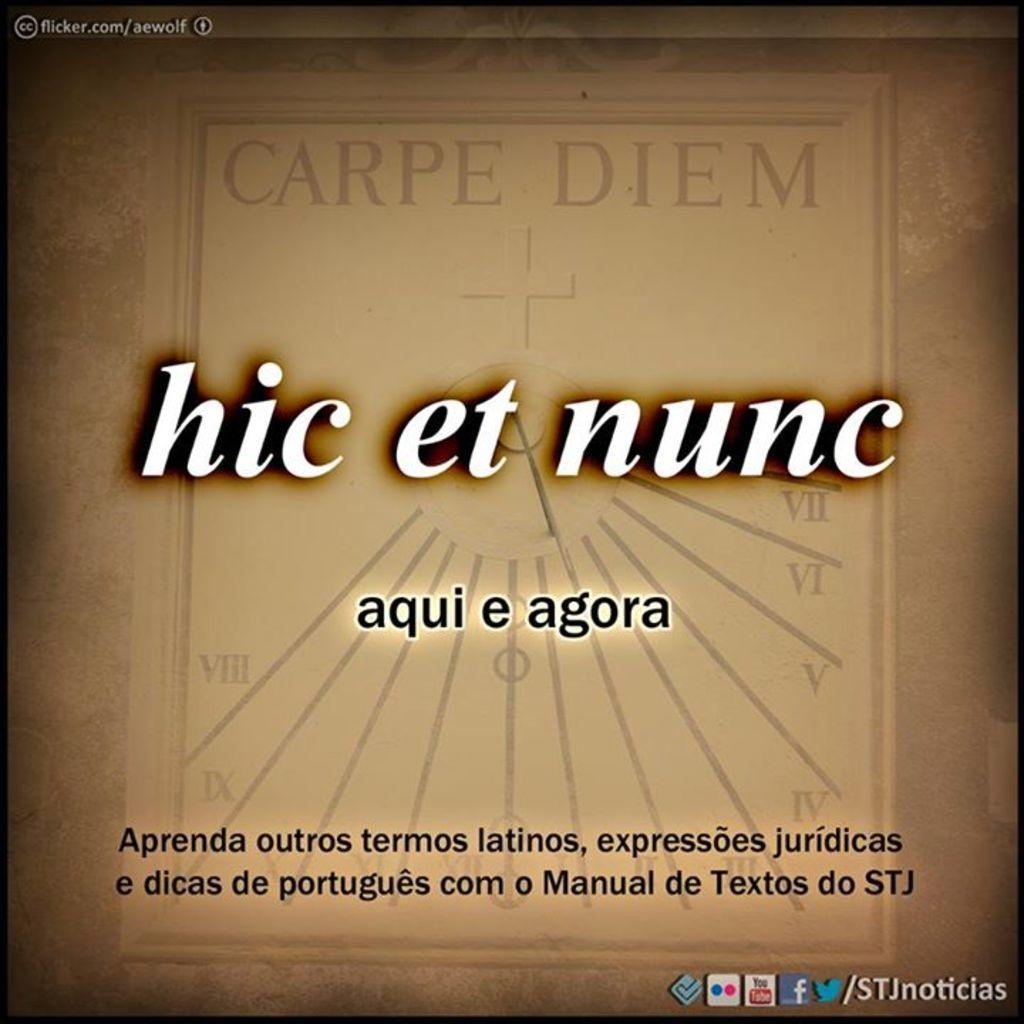<image>
Give a short and clear explanation of the subsequent image. A square with the words Carpe Diem at the top and hic et nunc near the middle 